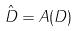Convert formula to latex. <formula><loc_0><loc_0><loc_500><loc_500>\hat { D } = A ( D )</formula> 